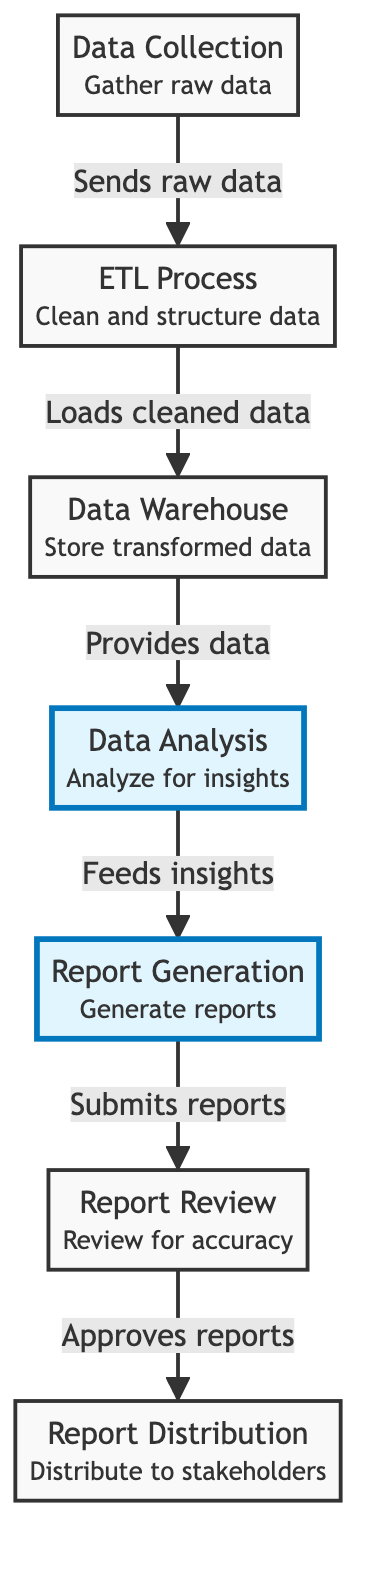What is the first node in the workflow? The first node listed in the diagram is "Data Collection," which gathers raw data from different sources.
Answer: Data Collection How many nodes are present in the diagram? Counting all unique nodes listed, there are seven nodes: Data Collection, ETL Process, Data Warehouse, Data Analysis, Report Generation, Report Review, and Report Distribution.
Answer: 7 What relationship exists between ETL Process and Data Warehouse? The diagram shows that the ETL Process "Loads cleaned data" to the Data Warehouse.
Answer: Loads cleaned data Which two nodes are directly connected after Report Review? After Report Review, the diagram indicates that it connects directly to Report Distribution.
Answer: Report Distribution What is the role of the Data Analysis node? The role of Data Analysis is to "Analyze data for key insights" as stated in the node description.
Answer: Analyze data for key insights What does the Report Generation node receive from Data Analysis? The Report Generation node receives "insights" according to the flow indicated in the diagram.
Answer: Insights Which node acts as a storage for transformed data? The Data Warehouse node is responsible for storing transformed data before further analysis.
Answer: Data Warehouse What type of workflow does this diagram represent? This diagram represents a "Data Workflow for Monthly Report Generation," indicating the processes involved from data collection to report distribution.
Answer: Data Workflow for Monthly Report Generation What happens after the Report Review node? After the Report Review, the reports are "approved for" distribution to the stakeholders, as shown by the directed edge.
Answer: Approved for distribution 